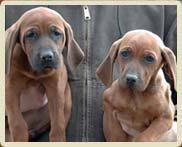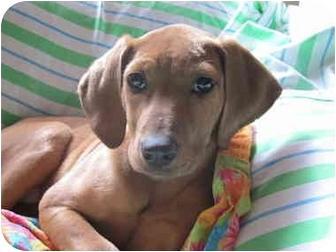The first image is the image on the left, the second image is the image on the right. For the images shown, is this caption "There are two dogs in the left image." true? Answer yes or no. Yes. The first image is the image on the left, the second image is the image on the right. Considering the images on both sides, is "There is a total of three dogs." valid? Answer yes or no. Yes. 